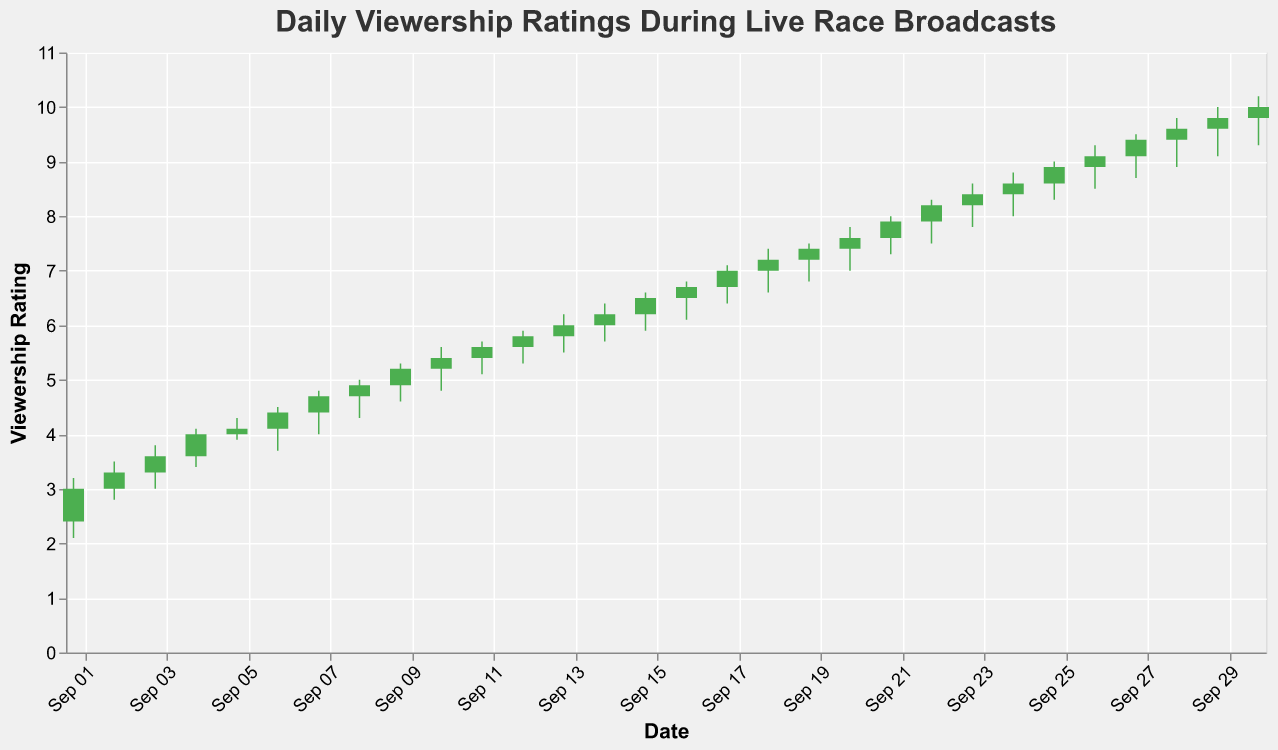What is the title of the plot? The title of the plot can be found at the top and it reads "Daily Viewership Ratings During Live Race Broadcasts".
Answer: Daily Viewership Ratings During Live Race Broadcasts What is the highest viewership rating recorded in September 2023? The highest point on the y-axis is 10.2, which appears on September 30th.
Answer: 10.2 How long did the viewership rating stay below 5? To determine this, look for data points where the closing rating was below 5. It rose and remained above 5 beginning September 10. Therefore, it was below 5 from September 1 to September 9, inclusive, which is 9 days.
Answer: 9 days Which days experienced a decline in viewership ratings by the end of the day? Days when the closing value is lower than the opening value indicate a decline. Based on this, the days with declining viewership are September 6, and September 19.
Answer: September 6, September 19 What is the largest daily viewership fluctuation in the month? To find this, calculate the difference between the highest and lowest ratings each day and identify the maximum fluctuation. The largest fluctuation is on September 6, with a high of 4.5 and a low of 3.7, giving a fluctuation of 0.8.
Answer: 0.8 How does the viewership rating on September 10 compare to that on September 20? On September 10, the closing rating is 5.4 and on September 20, the closing rating is 7.6. September 10 has a lower viewership compared to September 20.
Answer: Lower Which day had the highest opening viewership rating? The opening rating is the highest on September 30 with an open rating of 9.8.
Answer: September 30 What was the average closing rating for the month? Sum all the closing ratings for each day in September and divide by the number of days: (3.0 + 3.3 + 3.6 + 4.0 + 4.1 + 4.4 + 4.7 + 4.9 + 5.2 + 5.4 + 5.6 + 5.8 + 6.0 + 6.2 + 6.5 + 6.7 + 7.0 + 7.2 + 7.4 + 7.6 + 7.9 + 8.2 + 8.4 + 8.6 + 8.9 + 9.1 + 9.4 + 9.6 + 9.8 + 10.0)/30 = 6.53.
Answer: 6.53 On which date did the viewership rating first exceed 7.0? The first time the closing rating exceeded 7.0 was on September 17, with a closing rating of 7.0.
Answer: September 17 